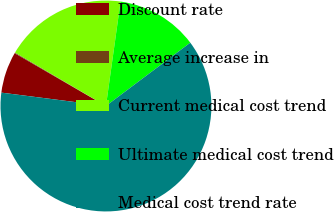<chart> <loc_0><loc_0><loc_500><loc_500><pie_chart><fcel>Discount rate<fcel>Average increase in<fcel>Current medical cost trend<fcel>Ultimate medical cost trend<fcel>Medical cost trend rate<nl><fcel>6.32%<fcel>0.11%<fcel>18.76%<fcel>12.54%<fcel>62.27%<nl></chart> 